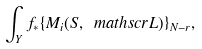<formula> <loc_0><loc_0><loc_500><loc_500>\int _ { Y } f _ { \ast } \{ M _ { i } ( S , \ m a t h s c r { L } ) \} _ { N - r } ,</formula> 